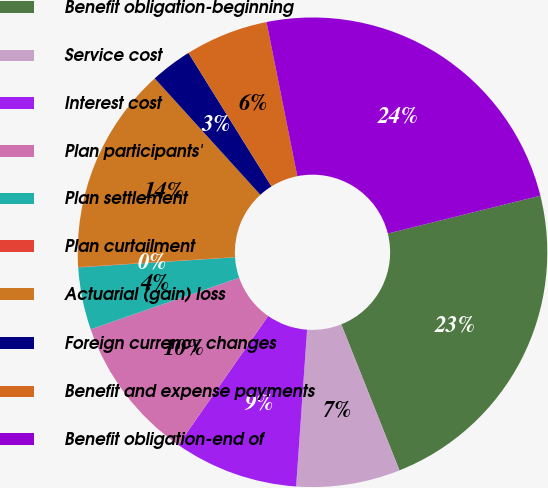Convert chart. <chart><loc_0><loc_0><loc_500><loc_500><pie_chart><fcel>Benefit obligation-beginning<fcel>Service cost<fcel>Interest cost<fcel>Plan participants'<fcel>Plan settlement<fcel>Plan curtailment<fcel>Actuarial (gain) loss<fcel>Foreign currency changes<fcel>Benefit and expense payments<fcel>Benefit obligation-end of<nl><fcel>22.84%<fcel>7.15%<fcel>8.57%<fcel>10.0%<fcel>4.29%<fcel>0.02%<fcel>14.28%<fcel>2.87%<fcel>5.72%<fcel>24.26%<nl></chart> 